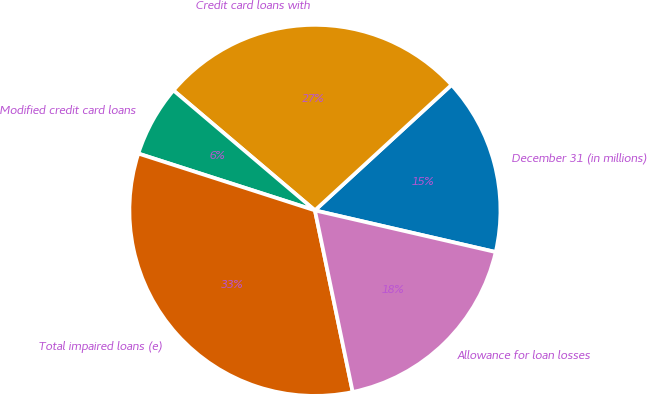Convert chart to OTSL. <chart><loc_0><loc_0><loc_500><loc_500><pie_chart><fcel>December 31 (in millions)<fcel>Credit card loans with<fcel>Modified credit card loans<fcel>Total impaired loans (e)<fcel>Allowance for loan losses<nl><fcel>15.43%<fcel>26.98%<fcel>6.24%<fcel>33.22%<fcel>18.13%<nl></chart> 